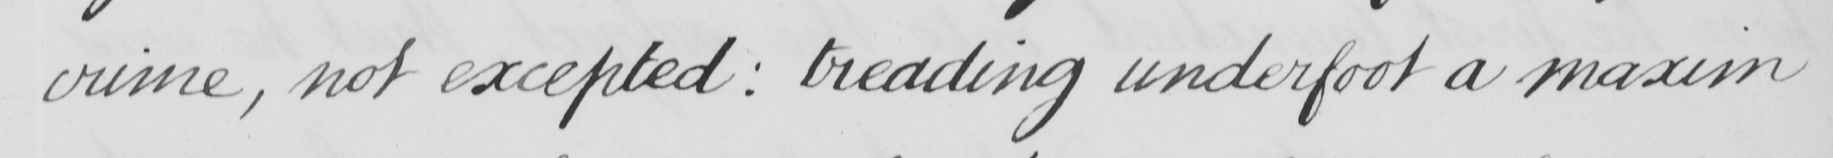What text is written in this handwritten line? crime , not excepted :  treading underfoot a maxim 